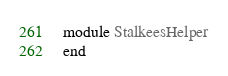<code> <loc_0><loc_0><loc_500><loc_500><_Ruby_>module StalkeesHelper
end
</code> 